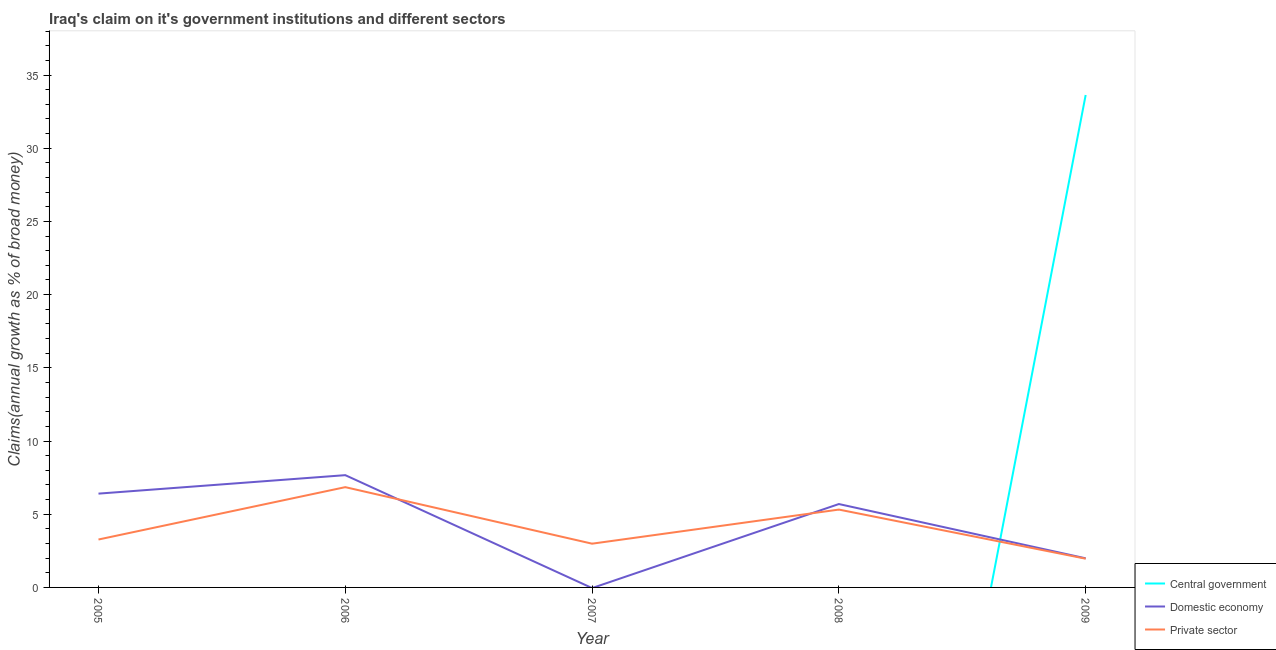How many different coloured lines are there?
Your response must be concise. 3. Does the line corresponding to percentage of claim on the central government intersect with the line corresponding to percentage of claim on the domestic economy?
Your response must be concise. Yes. Is the number of lines equal to the number of legend labels?
Keep it short and to the point. No. What is the percentage of claim on the private sector in 2008?
Keep it short and to the point. 5.32. Across all years, what is the maximum percentage of claim on the private sector?
Ensure brevity in your answer.  6.85. Across all years, what is the minimum percentage of claim on the private sector?
Keep it short and to the point. 1.96. What is the total percentage of claim on the private sector in the graph?
Ensure brevity in your answer.  20.39. What is the difference between the percentage of claim on the private sector in 2005 and that in 2006?
Give a very brief answer. -3.58. What is the difference between the percentage of claim on the central government in 2007 and the percentage of claim on the domestic economy in 2009?
Offer a very short reply. -1.99. What is the average percentage of claim on the private sector per year?
Give a very brief answer. 4.08. In the year 2009, what is the difference between the percentage of claim on the domestic economy and percentage of claim on the private sector?
Your answer should be compact. 0.03. In how many years, is the percentage of claim on the central government greater than 33 %?
Ensure brevity in your answer.  1. What is the ratio of the percentage of claim on the domestic economy in 2005 to that in 2008?
Offer a very short reply. 1.12. Is the percentage of claim on the domestic economy in 2005 less than that in 2009?
Your response must be concise. No. What is the difference between the highest and the second highest percentage of claim on the domestic economy?
Offer a terse response. 1.26. What is the difference between the highest and the lowest percentage of claim on the private sector?
Ensure brevity in your answer.  4.89. In how many years, is the percentage of claim on the central government greater than the average percentage of claim on the central government taken over all years?
Offer a very short reply. 1. Is it the case that in every year, the sum of the percentage of claim on the central government and percentage of claim on the domestic economy is greater than the percentage of claim on the private sector?
Your answer should be compact. No. Is the percentage of claim on the domestic economy strictly greater than the percentage of claim on the private sector over the years?
Ensure brevity in your answer.  No. Is the percentage of claim on the private sector strictly less than the percentage of claim on the domestic economy over the years?
Make the answer very short. No. How many years are there in the graph?
Provide a short and direct response. 5. Are the values on the major ticks of Y-axis written in scientific E-notation?
Make the answer very short. No. Does the graph contain any zero values?
Your response must be concise. Yes. Where does the legend appear in the graph?
Keep it short and to the point. Bottom right. What is the title of the graph?
Make the answer very short. Iraq's claim on it's government institutions and different sectors. What is the label or title of the X-axis?
Your response must be concise. Year. What is the label or title of the Y-axis?
Your answer should be compact. Claims(annual growth as % of broad money). What is the Claims(annual growth as % of broad money) of Central government in 2005?
Your answer should be very brief. 0. What is the Claims(annual growth as % of broad money) in Domestic economy in 2005?
Offer a very short reply. 6.41. What is the Claims(annual growth as % of broad money) in Private sector in 2005?
Offer a terse response. 3.27. What is the Claims(annual growth as % of broad money) in Central government in 2006?
Your answer should be very brief. 0. What is the Claims(annual growth as % of broad money) of Domestic economy in 2006?
Provide a succinct answer. 7.67. What is the Claims(annual growth as % of broad money) of Private sector in 2006?
Your answer should be compact. 6.85. What is the Claims(annual growth as % of broad money) in Central government in 2007?
Give a very brief answer. 0. What is the Claims(annual growth as % of broad money) in Domestic economy in 2007?
Your response must be concise. 0. What is the Claims(annual growth as % of broad money) in Private sector in 2007?
Provide a succinct answer. 2.99. What is the Claims(annual growth as % of broad money) in Central government in 2008?
Your answer should be very brief. 0. What is the Claims(annual growth as % of broad money) of Domestic economy in 2008?
Offer a very short reply. 5.7. What is the Claims(annual growth as % of broad money) in Private sector in 2008?
Keep it short and to the point. 5.32. What is the Claims(annual growth as % of broad money) of Central government in 2009?
Give a very brief answer. 33.64. What is the Claims(annual growth as % of broad money) in Domestic economy in 2009?
Your answer should be compact. 1.99. What is the Claims(annual growth as % of broad money) in Private sector in 2009?
Your answer should be very brief. 1.96. Across all years, what is the maximum Claims(annual growth as % of broad money) of Central government?
Offer a terse response. 33.64. Across all years, what is the maximum Claims(annual growth as % of broad money) in Domestic economy?
Provide a short and direct response. 7.67. Across all years, what is the maximum Claims(annual growth as % of broad money) of Private sector?
Offer a very short reply. 6.85. Across all years, what is the minimum Claims(annual growth as % of broad money) in Domestic economy?
Your response must be concise. 0. Across all years, what is the minimum Claims(annual growth as % of broad money) of Private sector?
Offer a very short reply. 1.96. What is the total Claims(annual growth as % of broad money) in Central government in the graph?
Keep it short and to the point. 33.64. What is the total Claims(annual growth as % of broad money) in Domestic economy in the graph?
Keep it short and to the point. 21.76. What is the total Claims(annual growth as % of broad money) of Private sector in the graph?
Provide a short and direct response. 20.39. What is the difference between the Claims(annual growth as % of broad money) of Domestic economy in 2005 and that in 2006?
Offer a terse response. -1.26. What is the difference between the Claims(annual growth as % of broad money) of Private sector in 2005 and that in 2006?
Offer a very short reply. -3.58. What is the difference between the Claims(annual growth as % of broad money) in Private sector in 2005 and that in 2007?
Provide a succinct answer. 0.28. What is the difference between the Claims(annual growth as % of broad money) of Domestic economy in 2005 and that in 2008?
Provide a short and direct response. 0.71. What is the difference between the Claims(annual growth as % of broad money) in Private sector in 2005 and that in 2008?
Give a very brief answer. -2.04. What is the difference between the Claims(annual growth as % of broad money) in Domestic economy in 2005 and that in 2009?
Give a very brief answer. 4.42. What is the difference between the Claims(annual growth as % of broad money) in Private sector in 2005 and that in 2009?
Provide a succinct answer. 1.31. What is the difference between the Claims(annual growth as % of broad money) in Private sector in 2006 and that in 2007?
Your answer should be very brief. 3.86. What is the difference between the Claims(annual growth as % of broad money) of Domestic economy in 2006 and that in 2008?
Ensure brevity in your answer.  1.97. What is the difference between the Claims(annual growth as % of broad money) in Private sector in 2006 and that in 2008?
Give a very brief answer. 1.53. What is the difference between the Claims(annual growth as % of broad money) in Domestic economy in 2006 and that in 2009?
Offer a terse response. 5.68. What is the difference between the Claims(annual growth as % of broad money) in Private sector in 2006 and that in 2009?
Offer a very short reply. 4.89. What is the difference between the Claims(annual growth as % of broad money) of Private sector in 2007 and that in 2008?
Give a very brief answer. -2.33. What is the difference between the Claims(annual growth as % of broad money) of Private sector in 2007 and that in 2009?
Ensure brevity in your answer.  1.03. What is the difference between the Claims(annual growth as % of broad money) of Domestic economy in 2008 and that in 2009?
Provide a succinct answer. 3.71. What is the difference between the Claims(annual growth as % of broad money) of Private sector in 2008 and that in 2009?
Give a very brief answer. 3.35. What is the difference between the Claims(annual growth as % of broad money) in Domestic economy in 2005 and the Claims(annual growth as % of broad money) in Private sector in 2006?
Provide a succinct answer. -0.44. What is the difference between the Claims(annual growth as % of broad money) of Domestic economy in 2005 and the Claims(annual growth as % of broad money) of Private sector in 2007?
Provide a succinct answer. 3.42. What is the difference between the Claims(annual growth as % of broad money) in Domestic economy in 2005 and the Claims(annual growth as % of broad money) in Private sector in 2008?
Offer a very short reply. 1.09. What is the difference between the Claims(annual growth as % of broad money) of Domestic economy in 2005 and the Claims(annual growth as % of broad money) of Private sector in 2009?
Offer a terse response. 4.44. What is the difference between the Claims(annual growth as % of broad money) in Domestic economy in 2006 and the Claims(annual growth as % of broad money) in Private sector in 2007?
Your answer should be compact. 4.68. What is the difference between the Claims(annual growth as % of broad money) in Domestic economy in 2006 and the Claims(annual growth as % of broad money) in Private sector in 2008?
Offer a very short reply. 2.35. What is the difference between the Claims(annual growth as % of broad money) of Domestic economy in 2006 and the Claims(annual growth as % of broad money) of Private sector in 2009?
Your answer should be very brief. 5.71. What is the difference between the Claims(annual growth as % of broad money) of Domestic economy in 2008 and the Claims(annual growth as % of broad money) of Private sector in 2009?
Your response must be concise. 3.73. What is the average Claims(annual growth as % of broad money) of Central government per year?
Make the answer very short. 6.73. What is the average Claims(annual growth as % of broad money) in Domestic economy per year?
Your answer should be compact. 4.35. What is the average Claims(annual growth as % of broad money) of Private sector per year?
Offer a terse response. 4.08. In the year 2005, what is the difference between the Claims(annual growth as % of broad money) of Domestic economy and Claims(annual growth as % of broad money) of Private sector?
Keep it short and to the point. 3.13. In the year 2006, what is the difference between the Claims(annual growth as % of broad money) of Domestic economy and Claims(annual growth as % of broad money) of Private sector?
Keep it short and to the point. 0.82. In the year 2008, what is the difference between the Claims(annual growth as % of broad money) in Domestic economy and Claims(annual growth as % of broad money) in Private sector?
Your answer should be compact. 0.38. In the year 2009, what is the difference between the Claims(annual growth as % of broad money) in Central government and Claims(annual growth as % of broad money) in Domestic economy?
Offer a terse response. 31.65. In the year 2009, what is the difference between the Claims(annual growth as % of broad money) of Central government and Claims(annual growth as % of broad money) of Private sector?
Offer a very short reply. 31.67. In the year 2009, what is the difference between the Claims(annual growth as % of broad money) of Domestic economy and Claims(annual growth as % of broad money) of Private sector?
Offer a very short reply. 0.03. What is the ratio of the Claims(annual growth as % of broad money) of Domestic economy in 2005 to that in 2006?
Your response must be concise. 0.84. What is the ratio of the Claims(annual growth as % of broad money) of Private sector in 2005 to that in 2006?
Provide a succinct answer. 0.48. What is the ratio of the Claims(annual growth as % of broad money) in Private sector in 2005 to that in 2007?
Provide a short and direct response. 1.1. What is the ratio of the Claims(annual growth as % of broad money) in Private sector in 2005 to that in 2008?
Keep it short and to the point. 0.62. What is the ratio of the Claims(annual growth as % of broad money) in Domestic economy in 2005 to that in 2009?
Provide a succinct answer. 3.22. What is the ratio of the Claims(annual growth as % of broad money) in Private sector in 2005 to that in 2009?
Your answer should be compact. 1.67. What is the ratio of the Claims(annual growth as % of broad money) in Private sector in 2006 to that in 2007?
Make the answer very short. 2.29. What is the ratio of the Claims(annual growth as % of broad money) in Domestic economy in 2006 to that in 2008?
Give a very brief answer. 1.35. What is the ratio of the Claims(annual growth as % of broad money) of Private sector in 2006 to that in 2008?
Offer a terse response. 1.29. What is the ratio of the Claims(annual growth as % of broad money) in Domestic economy in 2006 to that in 2009?
Your response must be concise. 3.86. What is the ratio of the Claims(annual growth as % of broad money) in Private sector in 2006 to that in 2009?
Give a very brief answer. 3.49. What is the ratio of the Claims(annual growth as % of broad money) of Private sector in 2007 to that in 2008?
Your response must be concise. 0.56. What is the ratio of the Claims(annual growth as % of broad money) of Private sector in 2007 to that in 2009?
Provide a succinct answer. 1.52. What is the ratio of the Claims(annual growth as % of broad money) in Domestic economy in 2008 to that in 2009?
Ensure brevity in your answer.  2.86. What is the ratio of the Claims(annual growth as % of broad money) in Private sector in 2008 to that in 2009?
Give a very brief answer. 2.71. What is the difference between the highest and the second highest Claims(annual growth as % of broad money) in Domestic economy?
Your answer should be compact. 1.26. What is the difference between the highest and the second highest Claims(annual growth as % of broad money) of Private sector?
Offer a terse response. 1.53. What is the difference between the highest and the lowest Claims(annual growth as % of broad money) of Central government?
Ensure brevity in your answer.  33.64. What is the difference between the highest and the lowest Claims(annual growth as % of broad money) in Domestic economy?
Give a very brief answer. 7.67. What is the difference between the highest and the lowest Claims(annual growth as % of broad money) in Private sector?
Make the answer very short. 4.89. 